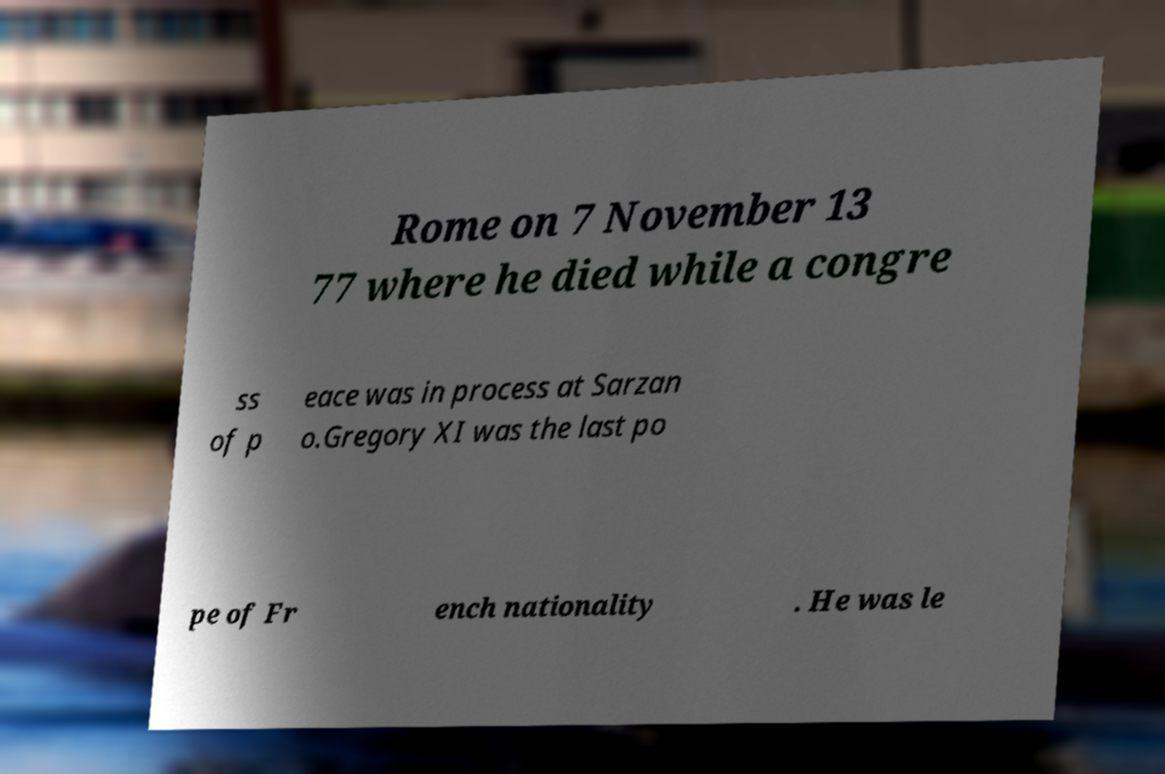Could you tell me more about Gregory XI mentioned in the image and his historical significance? Gregory XI was a pope in the 14th century, notable for being the last French pope and the last of the Avignon Papacy. His return to Rome in 1377 ended the Avignon Papacy, a period when the popes resided in Avignon, France. This move was significant in the history of the Catholic Church, as it marked a return to Rome, reestablishing the city as the spiritual center of the Church. 